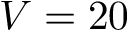<formula> <loc_0><loc_0><loc_500><loc_500>V = 2 0</formula> 